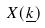<formula> <loc_0><loc_0><loc_500><loc_500>X ( \underline { k } )</formula> 